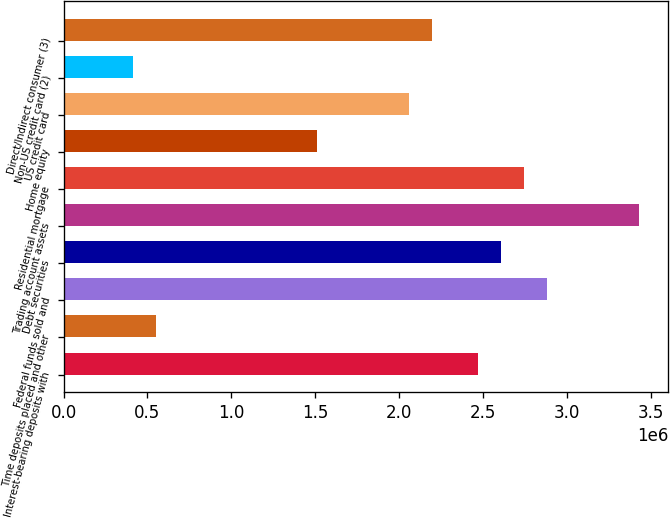Convert chart. <chart><loc_0><loc_0><loc_500><loc_500><bar_chart><fcel>Interest-bearing deposits with<fcel>Time deposits placed and other<fcel>Federal funds sold and<fcel>Debt securities<fcel>Trading account assets<fcel>Residential mortgage<fcel>Home equity<fcel>US credit card<fcel>Non-US credit card (2)<fcel>Direct/Indirect consumer (3)<nl><fcel>2.47165e+06<fcel>550039<fcel>2.88343e+06<fcel>2.60891e+06<fcel>3.43246e+06<fcel>2.74617e+06<fcel>1.51085e+06<fcel>2.05988e+06<fcel>412781<fcel>2.19714e+06<nl></chart> 